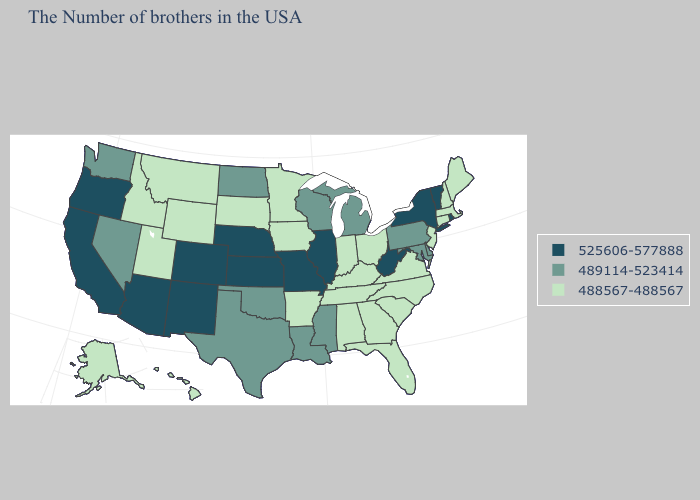Name the states that have a value in the range 525606-577888?
Be succinct. Rhode Island, Vermont, New York, West Virginia, Illinois, Missouri, Kansas, Nebraska, Colorado, New Mexico, Arizona, California, Oregon. Name the states that have a value in the range 489114-523414?
Be succinct. Delaware, Maryland, Pennsylvania, Michigan, Wisconsin, Mississippi, Louisiana, Oklahoma, Texas, North Dakota, Nevada, Washington. Among the states that border New Jersey , which have the lowest value?
Concise answer only. Delaware, Pennsylvania. Among the states that border Tennessee , does Missouri have the lowest value?
Short answer required. No. Does Colorado have the highest value in the USA?
Give a very brief answer. Yes. What is the lowest value in the South?
Be succinct. 488567-488567. Name the states that have a value in the range 489114-523414?
Quick response, please. Delaware, Maryland, Pennsylvania, Michigan, Wisconsin, Mississippi, Louisiana, Oklahoma, Texas, North Dakota, Nevada, Washington. Name the states that have a value in the range 525606-577888?
Answer briefly. Rhode Island, Vermont, New York, West Virginia, Illinois, Missouri, Kansas, Nebraska, Colorado, New Mexico, Arizona, California, Oregon. What is the lowest value in the MidWest?
Write a very short answer. 488567-488567. Is the legend a continuous bar?
Give a very brief answer. No. Does the first symbol in the legend represent the smallest category?
Short answer required. No. Does Tennessee have the same value as New Jersey?
Write a very short answer. Yes. What is the highest value in states that border Massachusetts?
Concise answer only. 525606-577888. Name the states that have a value in the range 525606-577888?
Short answer required. Rhode Island, Vermont, New York, West Virginia, Illinois, Missouri, Kansas, Nebraska, Colorado, New Mexico, Arizona, California, Oregon. Does Minnesota have a lower value than Vermont?
Quick response, please. Yes. 